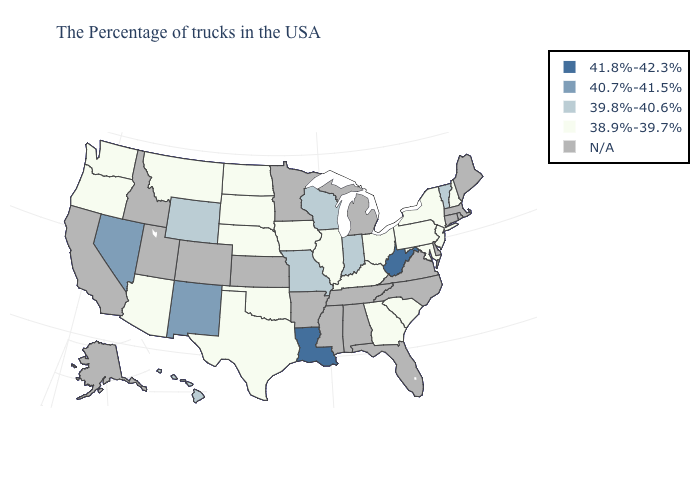Does South Carolina have the lowest value in the South?
Concise answer only. Yes. Name the states that have a value in the range 40.7%-41.5%?
Be succinct. New Mexico, Nevada. Name the states that have a value in the range N/A?
Keep it brief. Maine, Massachusetts, Rhode Island, Connecticut, Delaware, Virginia, North Carolina, Florida, Michigan, Alabama, Tennessee, Mississippi, Arkansas, Minnesota, Kansas, Colorado, Utah, Idaho, California, Alaska. What is the highest value in the Northeast ?
Quick response, please. 39.8%-40.6%. Name the states that have a value in the range N/A?
Short answer required. Maine, Massachusetts, Rhode Island, Connecticut, Delaware, Virginia, North Carolina, Florida, Michigan, Alabama, Tennessee, Mississippi, Arkansas, Minnesota, Kansas, Colorado, Utah, Idaho, California, Alaska. Which states have the highest value in the USA?
Give a very brief answer. West Virginia, Louisiana. What is the lowest value in the USA?
Short answer required. 38.9%-39.7%. Which states have the lowest value in the South?
Short answer required. Maryland, South Carolina, Georgia, Kentucky, Oklahoma, Texas. Which states have the lowest value in the USA?
Quick response, please. New Hampshire, New York, New Jersey, Maryland, Pennsylvania, South Carolina, Ohio, Georgia, Kentucky, Illinois, Iowa, Nebraska, Oklahoma, Texas, South Dakota, North Dakota, Montana, Arizona, Washington, Oregon. Among the states that border Arkansas , does Missouri have the lowest value?
Answer briefly. No. What is the highest value in the MidWest ?
Write a very short answer. 39.8%-40.6%. Does Nebraska have the highest value in the MidWest?
Answer briefly. No. Which states have the highest value in the USA?
Be succinct. West Virginia, Louisiana. Name the states that have a value in the range 41.8%-42.3%?
Concise answer only. West Virginia, Louisiana. 